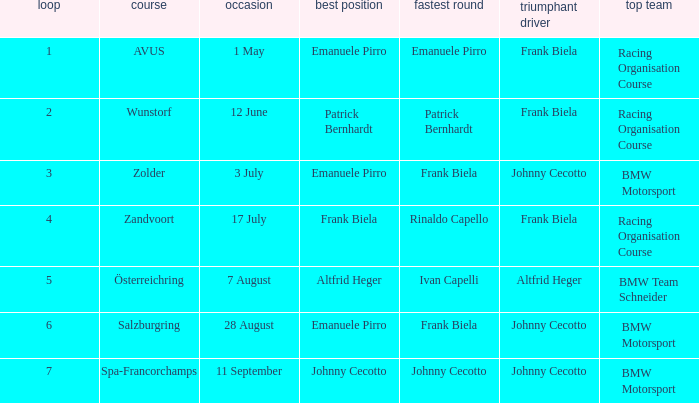What round was circuit Avus? 1.0. 